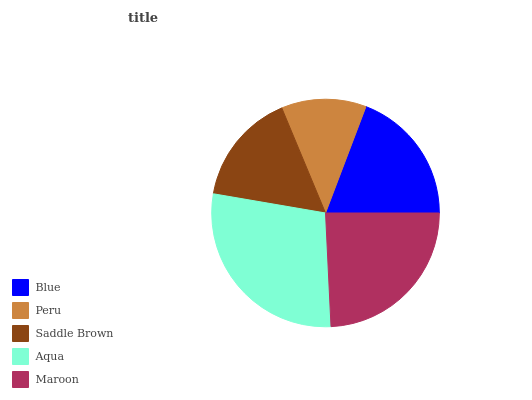Is Peru the minimum?
Answer yes or no. Yes. Is Aqua the maximum?
Answer yes or no. Yes. Is Saddle Brown the minimum?
Answer yes or no. No. Is Saddle Brown the maximum?
Answer yes or no. No. Is Saddle Brown greater than Peru?
Answer yes or no. Yes. Is Peru less than Saddle Brown?
Answer yes or no. Yes. Is Peru greater than Saddle Brown?
Answer yes or no. No. Is Saddle Brown less than Peru?
Answer yes or no. No. Is Blue the high median?
Answer yes or no. Yes. Is Blue the low median?
Answer yes or no. Yes. Is Peru the high median?
Answer yes or no. No. Is Maroon the low median?
Answer yes or no. No. 